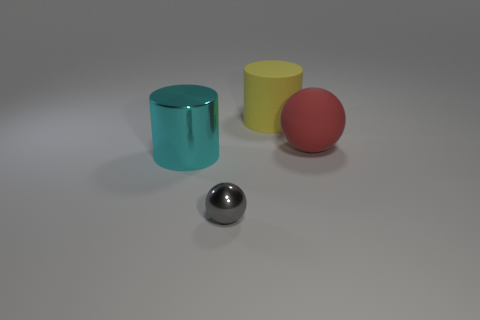If the objects in this image represented a family, who would be who? If we were to imagine these objects as a family, the sturdy yellow cylinder could be seen as a dependable parent, firm and stable. The cyan cylinder with its reflective surface might represent a cool and slightly elusive teenager. The red ball, with its vibrant color and matte texture, could symbolize a younger, spirited child full of energy. Lastly, the shiny sphere could be like the wizened grandparent, with a mirrored surface reflecting years of wisdom and memories. 